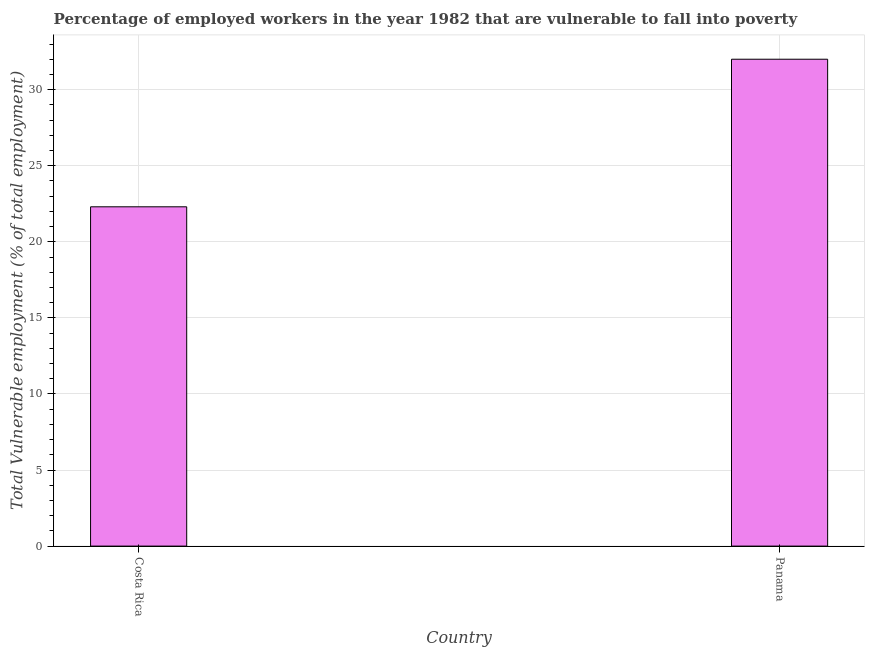What is the title of the graph?
Offer a very short reply. Percentage of employed workers in the year 1982 that are vulnerable to fall into poverty. What is the label or title of the Y-axis?
Your response must be concise. Total Vulnerable employment (% of total employment). What is the total vulnerable employment in Costa Rica?
Provide a short and direct response. 22.3. Across all countries, what is the maximum total vulnerable employment?
Your answer should be compact. 32. Across all countries, what is the minimum total vulnerable employment?
Keep it short and to the point. 22.3. In which country was the total vulnerable employment maximum?
Give a very brief answer. Panama. In which country was the total vulnerable employment minimum?
Offer a terse response. Costa Rica. What is the sum of the total vulnerable employment?
Your answer should be very brief. 54.3. What is the average total vulnerable employment per country?
Make the answer very short. 27.15. What is the median total vulnerable employment?
Ensure brevity in your answer.  27.15. In how many countries, is the total vulnerable employment greater than 13 %?
Keep it short and to the point. 2. What is the ratio of the total vulnerable employment in Costa Rica to that in Panama?
Keep it short and to the point. 0.7. Is the total vulnerable employment in Costa Rica less than that in Panama?
Keep it short and to the point. Yes. How many countries are there in the graph?
Give a very brief answer. 2. What is the difference between two consecutive major ticks on the Y-axis?
Give a very brief answer. 5. What is the Total Vulnerable employment (% of total employment) of Costa Rica?
Offer a terse response. 22.3. What is the ratio of the Total Vulnerable employment (% of total employment) in Costa Rica to that in Panama?
Ensure brevity in your answer.  0.7. 